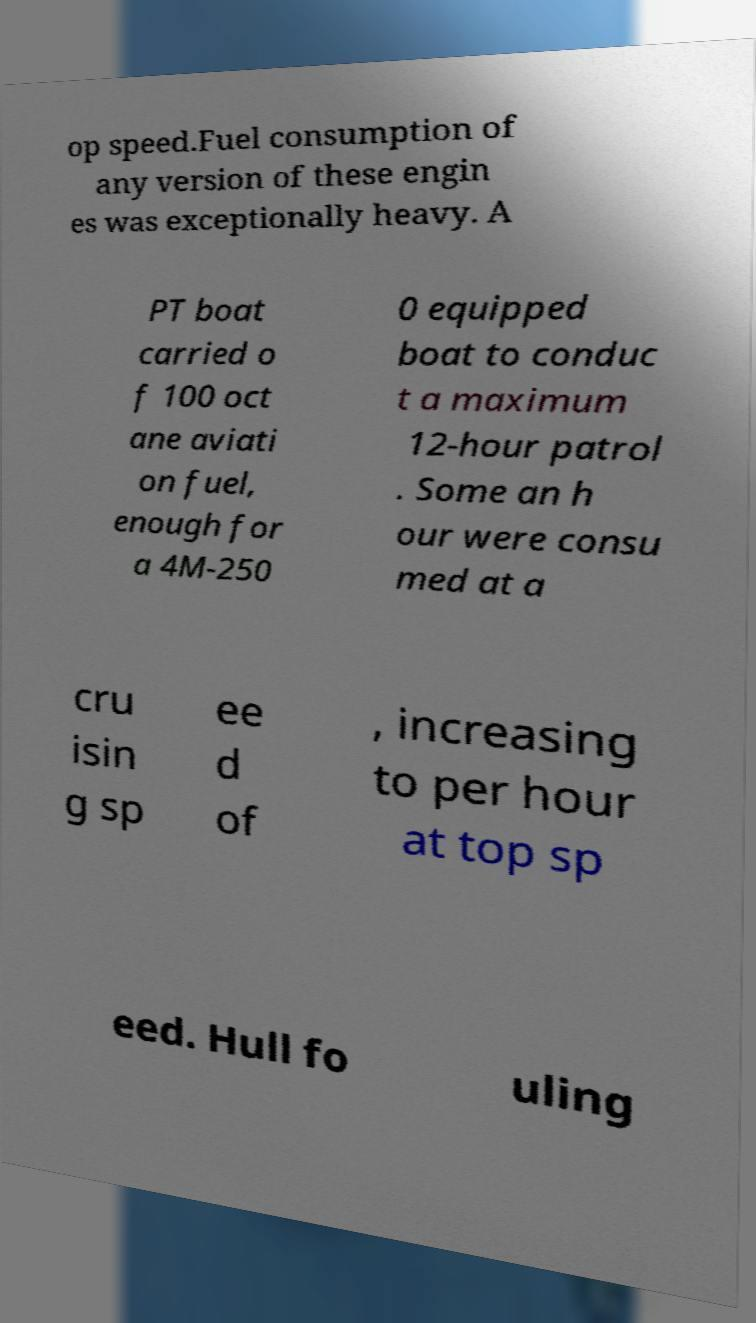Could you extract and type out the text from this image? op speed.Fuel consumption of any version of these engin es was exceptionally heavy. A PT boat carried o f 100 oct ane aviati on fuel, enough for a 4M-250 0 equipped boat to conduc t a maximum 12-hour patrol . Some an h our were consu med at a cru isin g sp ee d of , increasing to per hour at top sp eed. Hull fo uling 